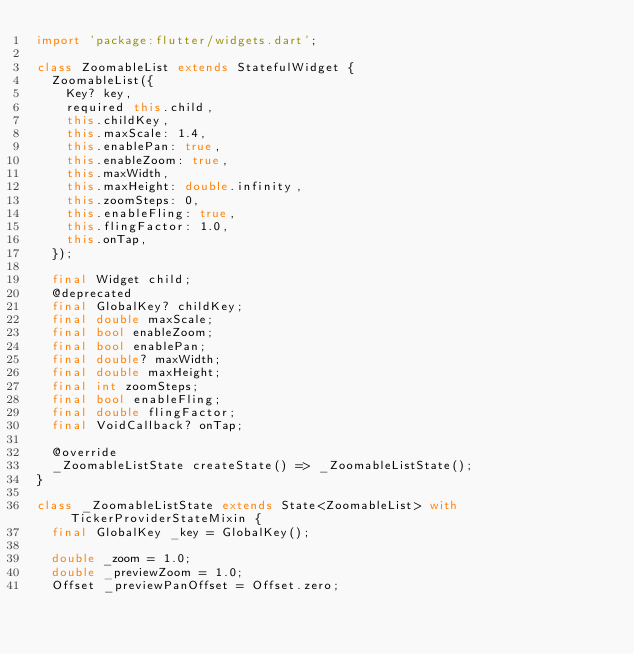<code> <loc_0><loc_0><loc_500><loc_500><_Dart_>import 'package:flutter/widgets.dart';

class ZoomableList extends StatefulWidget {
  ZoomableList({
    Key? key,
    required this.child,
    this.childKey,
    this.maxScale: 1.4,
    this.enablePan: true,
    this.enableZoom: true,
    this.maxWidth,
    this.maxHeight: double.infinity,
    this.zoomSteps: 0,
    this.enableFling: true,
    this.flingFactor: 1.0,
    this.onTap,
  });

  final Widget child;
  @deprecated
  final GlobalKey? childKey;
  final double maxScale;
  final bool enableZoom;
  final bool enablePan;
  final double? maxWidth;
  final double maxHeight;
  final int zoomSteps;
  final bool enableFling;
  final double flingFactor;
  final VoidCallback? onTap;

  @override
  _ZoomableListState createState() => _ZoomableListState();
}

class _ZoomableListState extends State<ZoomableList> with TickerProviderStateMixin {
  final GlobalKey _key = GlobalKey();

  double _zoom = 1.0;
  double _previewZoom = 1.0;
  Offset _previewPanOffset = Offset.zero;</code> 